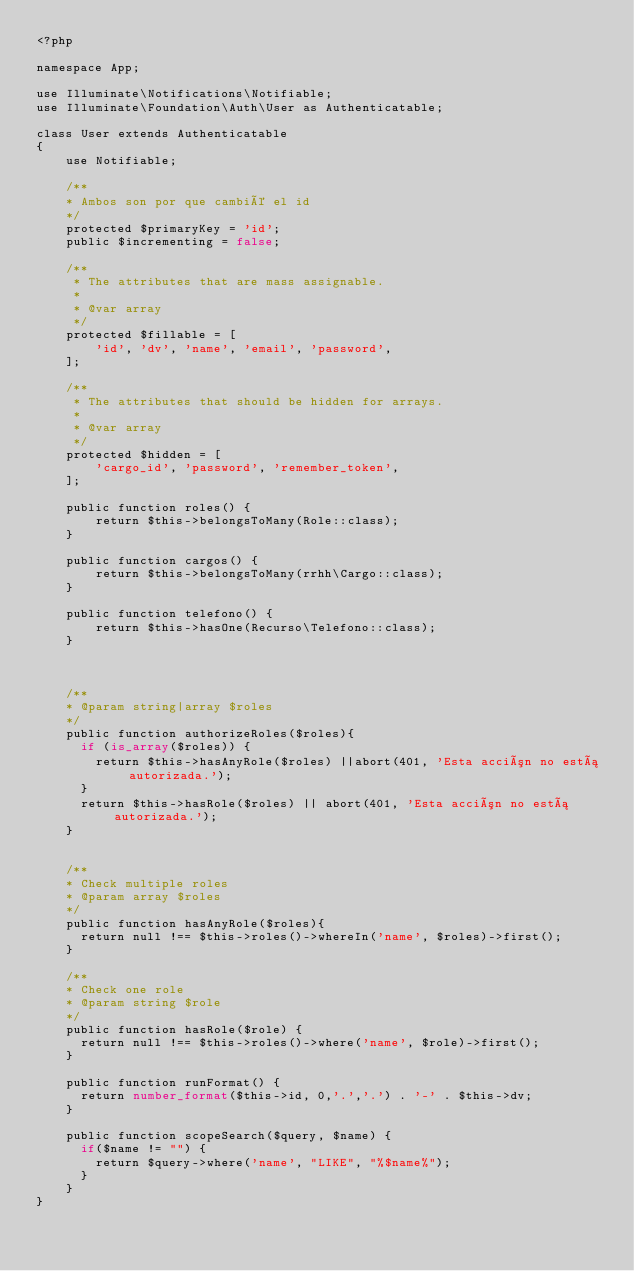<code> <loc_0><loc_0><loc_500><loc_500><_PHP_><?php

namespace App;

use Illuminate\Notifications\Notifiable;
use Illuminate\Foundation\Auth\User as Authenticatable;

class User extends Authenticatable
{
    use Notifiable;

    /**
    * Ambos son por que cambié el id
    */
    protected $primaryKey = 'id';
    public $incrementing = false;

    /**
     * The attributes that are mass assignable.
     *
     * @var array
     */
    protected $fillable = [
        'id', 'dv', 'name', 'email', 'password',
    ];

    /**
     * The attributes that should be hidden for arrays.
     *
     * @var array
     */
    protected $hidden = [
        'cargo_id', 'password', 'remember_token',
    ];

    public function roles() {
        return $this->belongsToMany(Role::class);
    }

    public function cargos() {
        return $this->belongsToMany(rrhh\Cargo::class);
    }

    public function telefono() {
        return $this->hasOne(Recurso\Telefono::class);
    }

    

    /**
    * @param string|array $roles
    */
    public function authorizeRoles($roles){
      if (is_array($roles)) {
        return $this->hasAnyRole($roles) ||abort(401, 'Esta acción no está autorizada.');
      } 
      return $this->hasRole($roles) || abort(401, 'Esta acción no está autorizada.');
    }


    /**
    * Check multiple roles
    * @param array $roles
    */
    public function hasAnyRole($roles){
      return null !== $this->roles()->whereIn('name', $roles)->first();
    }

    /**
    * Check one role
    * @param string $role
    */
    public function hasRole($role) {
      return null !== $this->roles()->where('name', $role)->first();
    }

    public function runFormat() {
      return number_format($this->id, 0,'.','.') . '-' . $this->dv;
    }

    public function scopeSearch($query, $name) {
      if($name != "") {
        return $query->where('name', "LIKE", "%$name%");  
      }  
    }
}
</code> 